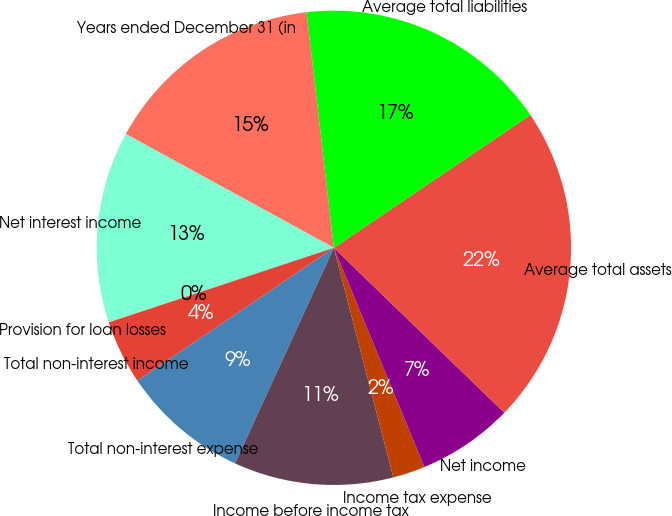Convert chart. <chart><loc_0><loc_0><loc_500><loc_500><pie_chart><fcel>Years ended December 31 (in<fcel>Net interest income<fcel>Provision for loan losses<fcel>Total non-interest income<fcel>Total non-interest expense<fcel>Income before income tax<fcel>Income tax expense<fcel>Net income<fcel>Average total assets<fcel>Average total liabilities<nl><fcel>15.2%<fcel>13.03%<fcel>0.03%<fcel>4.37%<fcel>8.7%<fcel>10.87%<fcel>2.2%<fcel>6.53%<fcel>21.7%<fcel>17.37%<nl></chart> 